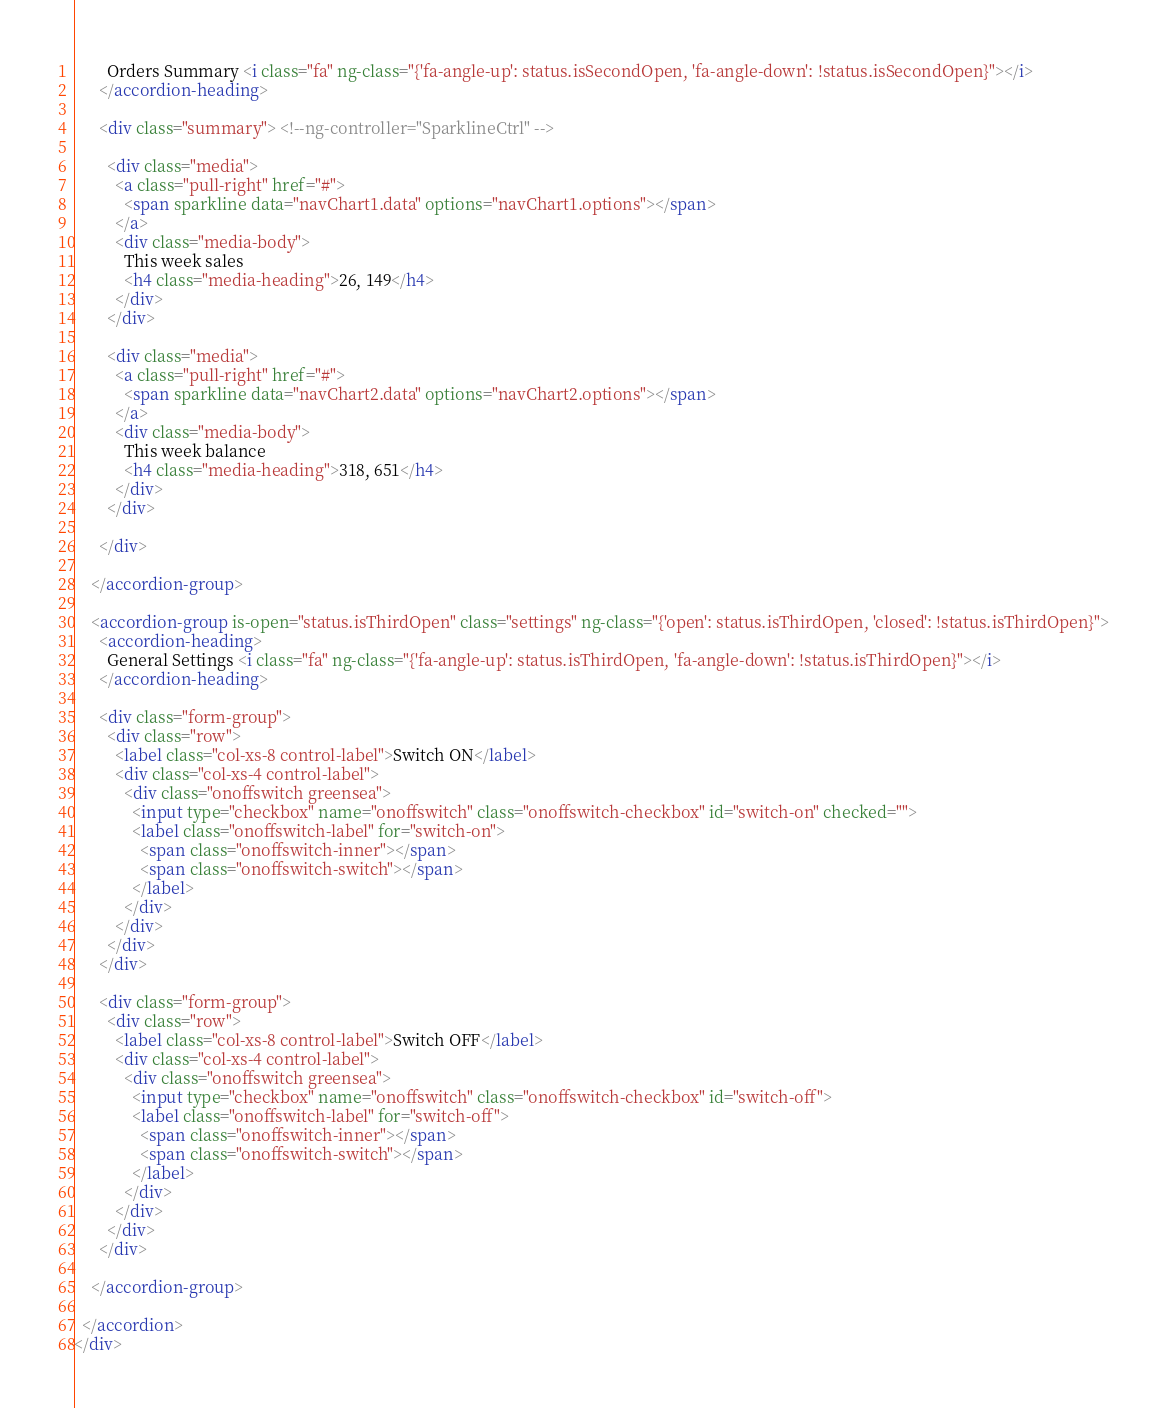Convert code to text. <code><loc_0><loc_0><loc_500><loc_500><_HTML_>        Orders Summary <i class="fa" ng-class="{'fa-angle-up': status.isSecondOpen, 'fa-angle-down': !status.isSecondOpen}"></i>
      </accordion-heading>

      <div class="summary"> <!--ng-controller="SparklineCtrl" -->

        <div class="media">
          <a class="pull-right" href="#">
            <span sparkline data="navChart1.data" options="navChart1.options"></span>
          </a>
          <div class="media-body">
            This week sales
            <h4 class="media-heading">26, 149</h4>
          </div>
        </div>

        <div class="media">
          <a class="pull-right" href="#">
            <span sparkline data="navChart2.data" options="navChart2.options"></span>
          </a>
          <div class="media-body">
            This week balance
            <h4 class="media-heading">318, 651</h4>
          </div>
        </div>

      </div>

    </accordion-group>

    <accordion-group is-open="status.isThirdOpen" class="settings" ng-class="{'open': status.isThirdOpen, 'closed': !status.isThirdOpen}">
      <accordion-heading>
        General Settings <i class="fa" ng-class="{'fa-angle-up': status.isThirdOpen, 'fa-angle-down': !status.isThirdOpen}"></i>
      </accordion-heading>

      <div class="form-group">
        <div class="row">
          <label class="col-xs-8 control-label">Switch ON</label>
          <div class="col-xs-4 control-label">
            <div class="onoffswitch greensea">
              <input type="checkbox" name="onoffswitch" class="onoffswitch-checkbox" id="switch-on" checked="">
              <label class="onoffswitch-label" for="switch-on">
                <span class="onoffswitch-inner"></span>
                <span class="onoffswitch-switch"></span>
              </label>
            </div>
          </div>
        </div>
      </div>

      <div class="form-group">
        <div class="row">
          <label class="col-xs-8 control-label">Switch OFF</label>
          <div class="col-xs-4 control-label">
            <div class="onoffswitch greensea">
              <input type="checkbox" name="onoffswitch" class="onoffswitch-checkbox" id="switch-off">
              <label class="onoffswitch-label" for="switch-off">
                <span class="onoffswitch-inner"></span>
                <span class="onoffswitch-switch"></span>
              </label>
            </div>
          </div>
        </div>
      </div>

    </accordion-group>

  </accordion>
</div>
</code> 